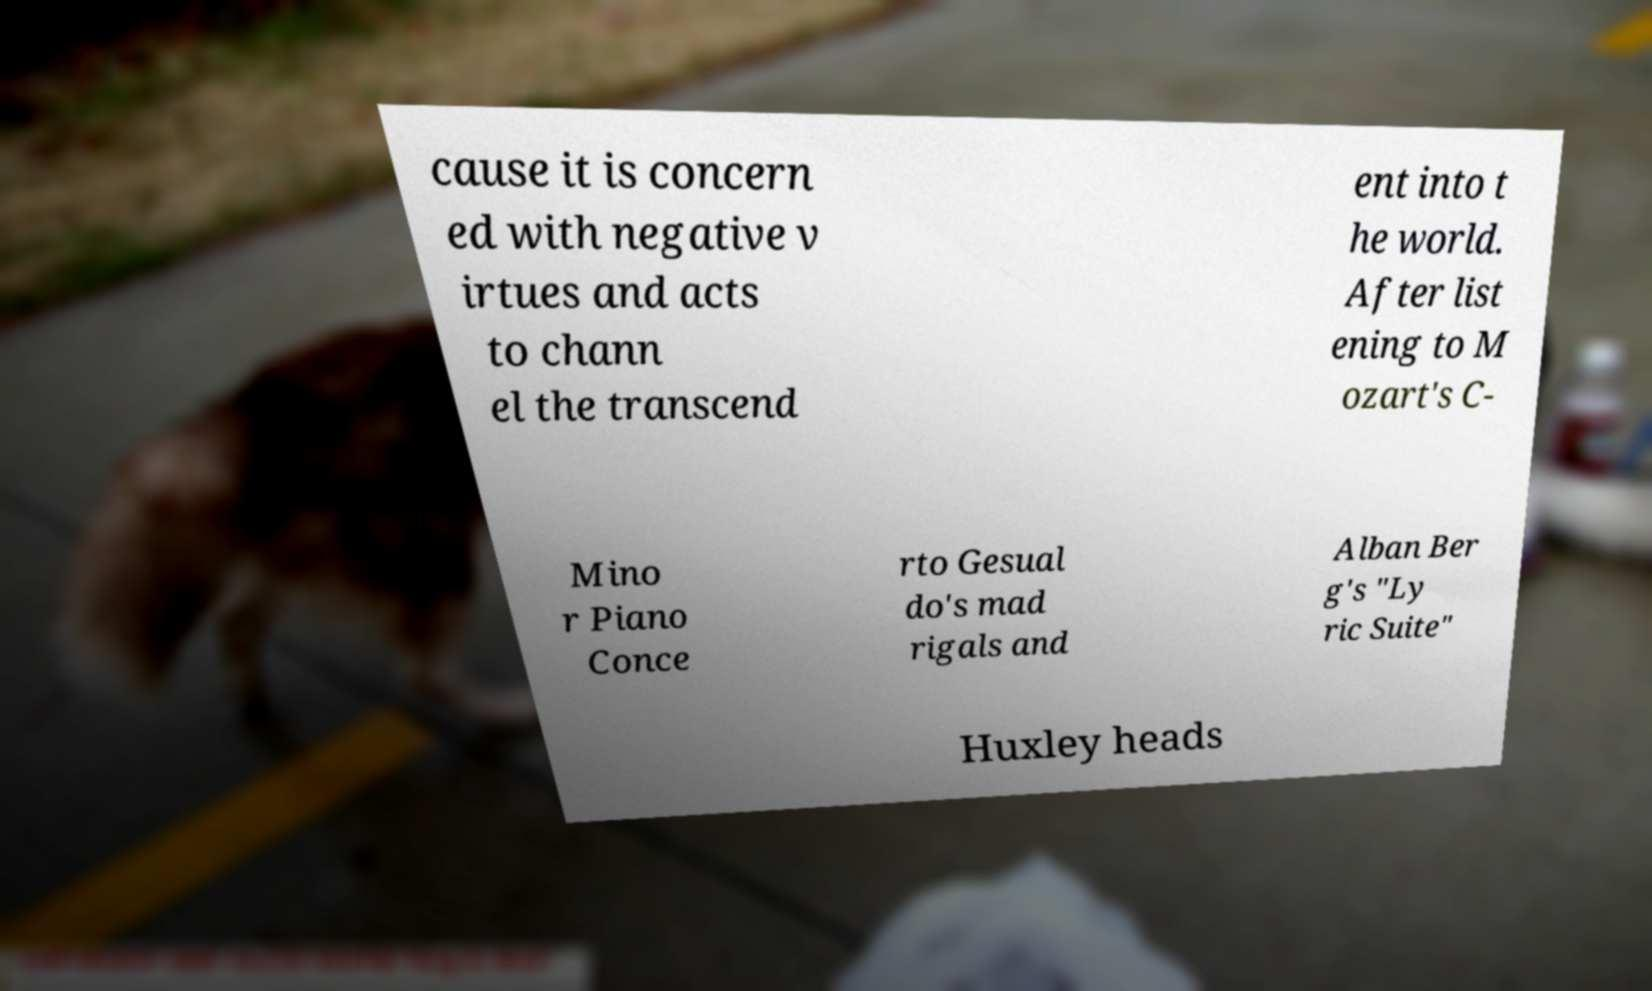Please identify and transcribe the text found in this image. cause it is concern ed with negative v irtues and acts to chann el the transcend ent into t he world. After list ening to M ozart's C- Mino r Piano Conce rto Gesual do's mad rigals and Alban Ber g's "Ly ric Suite" Huxley heads 